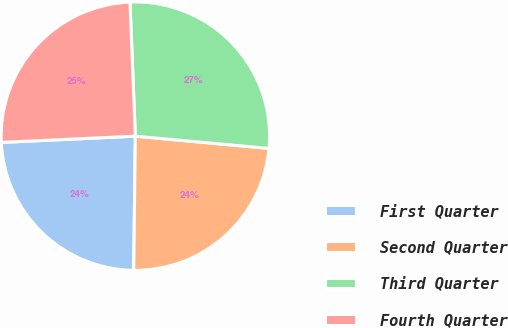Convert chart. <chart><loc_0><loc_0><loc_500><loc_500><pie_chart><fcel>First Quarter<fcel>Second Quarter<fcel>Third Quarter<fcel>Fourth Quarter<nl><fcel>24.07%<fcel>23.74%<fcel>27.09%<fcel>25.1%<nl></chart> 